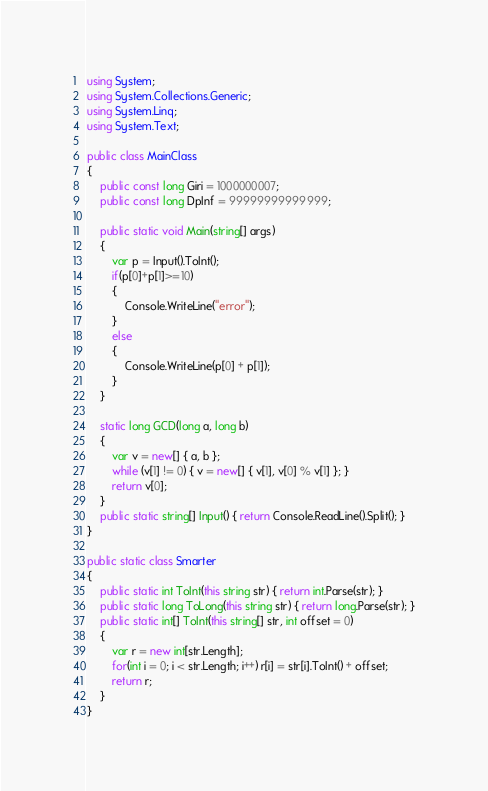Convert code to text. <code><loc_0><loc_0><loc_500><loc_500><_C#_>using System;
using System.Collections.Generic;
using System.Linq;
using System.Text;

public class MainClass
{
	public const long Giri = 1000000007;
	public const long DpInf = 99999999999999;
	
	public static void Main(string[] args)
	{
		var p = Input().ToInt();
		if(p[0]+p[1]>=10)
		{
			Console.WriteLine("error");
		}
		else
		{
			Console.WriteLine(p[0] + p[1]);
		}
	}
	
	static long GCD(long a, long b)
	{
		var v = new[] { a, b };
		while (v[1] != 0) { v = new[] { v[1], v[0] % v[1] }; }
		return v[0];
	}
	public static string[] Input() { return Console.ReadLine().Split(); }
}

public static class Smarter
{
	public static int ToInt(this string str) { return int.Parse(str); }
	public static long ToLong(this string str) { return long.Parse(str); }
	public static int[] ToInt(this string[] str, int offset = 0)
	{
		var r = new int[str.Length];
		for(int i = 0; i < str.Length; i++) r[i] = str[i].ToInt() + offset;
		return r;
	}
}</code> 